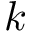Convert formula to latex. <formula><loc_0><loc_0><loc_500><loc_500>k</formula> 